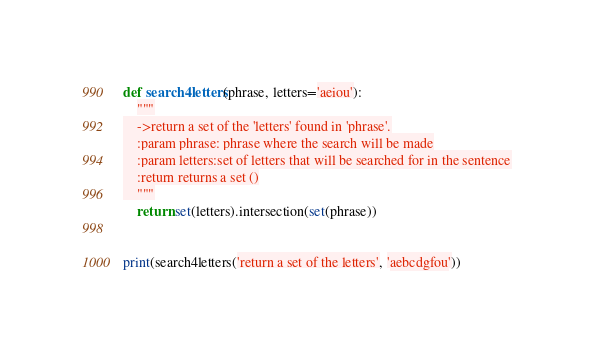<code> <loc_0><loc_0><loc_500><loc_500><_Python_>def search4letters(phrase, letters='aeiou'):
    """
    ->return a set of the 'letters' found in 'phrase'.
    :param phrase: phrase where the search will be made
    :param letters:set of letters that will be searched for in the sentence
    :return returns a set ()
    """
    return set(letters).intersection(set(phrase))


print(search4letters('return a set of the letters', 'aebcdgfou'))
</code> 